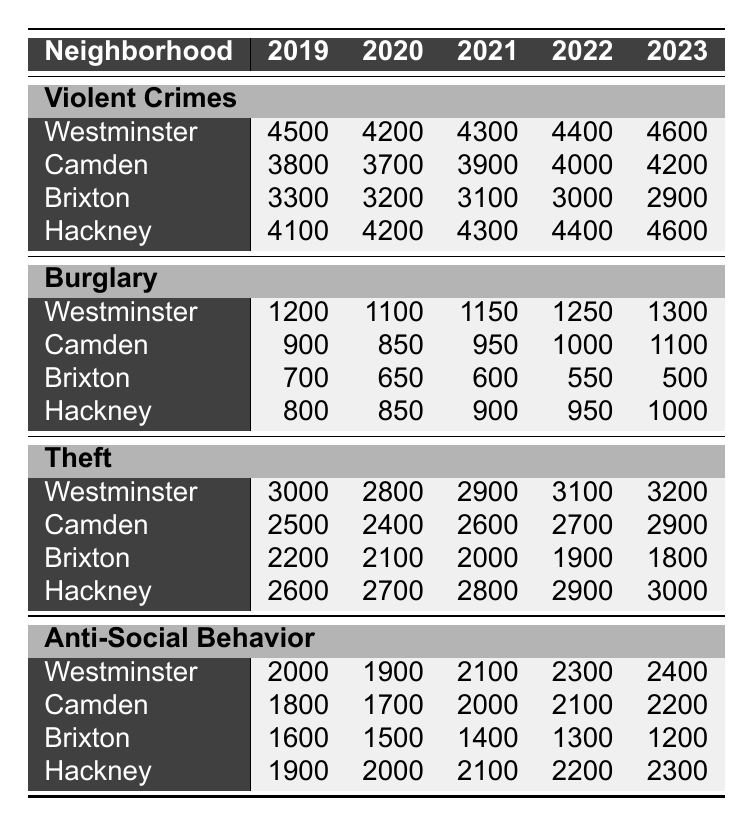What was the total number of violent crimes in Westminster in 2022? To find this, we look for the violent crimes in the Westminster row for the year 2022. According to the table, the number is 4400.
Answer: 4400 How many burglaries were reported in Camden in 2020? The table shows that in Camden for the year 2020, the number of burglaries is 850.
Answer: 850 Which neighborhood had the highest number of thefts in 2023? By examining the theft counts for each neighborhood in 2023, Westminster has 3200 thefts, Camden has 2900, Brixton has 1800, and Hackney has 3000. The highest is in Westminster.
Answer: Westminster What is the average number of anti-social behavior incidents in Brixton from 2019 to 2023? To find this average, we sum the anti-social behavior incidents for Brixton from each year: (1600 + 1500 + 1400 + 1300 + 1200) = 8000. Then, we divide by 5 years: 8000/5 = 1600.
Answer: 1600 Did the number of violent crimes in Hackney increase or decrease from 2019 to 2023? We look at the violent crimes for Hackney in these two years: in 2019, there were 4100 violent crimes, and in 2023 it was 4600. Since 4600 > 4100, this is an increase.
Answer: Increase Which neighborhood saw the largest decrease in burglary from 2019 to 2023? To compare the decreases, we find the burglary numbers: Westminster (1200 to 1300, increase), Camden (900 to 1100, increase), Brixton (700 to 500, decrease of 200), and Hackney (800 to 1000, increase). Brixton shows the largest decrease.
Answer: Brixton What was the total number of violent crimes across all neighborhoods in 2021? We find the violent crime counts for each neighborhood in 2021: Westminster (4300), Camden (3900), Brixton (3100), and Hackney (4300). Summing these gives us: 4300 + 3900 + 3100 + 4300 = 15600.
Answer: 15600 In which year did Camden experience the most significant increase in violent crimes compared to the previous year? By comparing the violent crime numbers for Camden each year: 3800 (2019) to 3700 (2020: decrease), 3700 to 3900 (2021: increase of 200), 3900 to 4000 (2022: increase of 100), and 4000 to 4200 (2023: increase of 200). The most significant increase was from 2020 to 2021.
Answer: 2021 How many more anti-social behavior incidents did Westminster have compared to Brixton in 2023? For Westminster in 2023, there were 2400 incidents and for Brixton, there were 1200. The difference is 2400 - 1200 = 1200.
Answer: 1200 